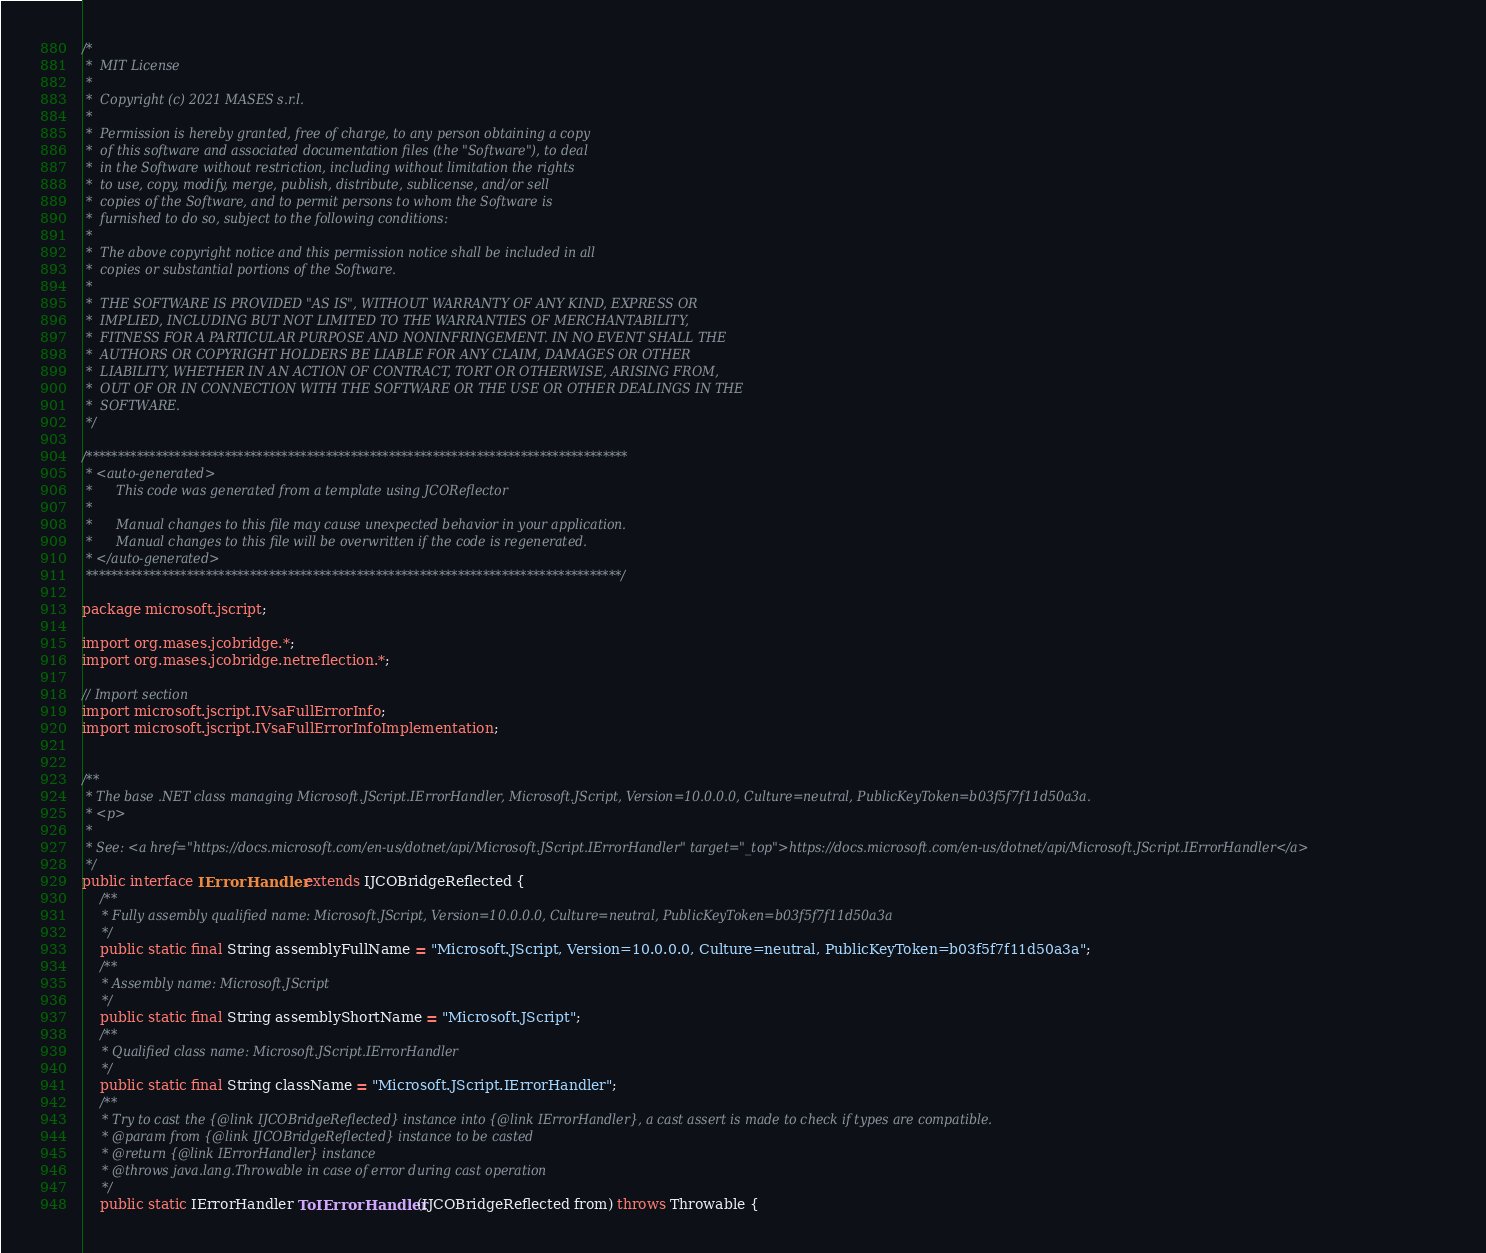Convert code to text. <code><loc_0><loc_0><loc_500><loc_500><_Java_>/*
 *  MIT License
 *
 *  Copyright (c) 2021 MASES s.r.l.
 *
 *  Permission is hereby granted, free of charge, to any person obtaining a copy
 *  of this software and associated documentation files (the "Software"), to deal
 *  in the Software without restriction, including without limitation the rights
 *  to use, copy, modify, merge, publish, distribute, sublicense, and/or sell
 *  copies of the Software, and to permit persons to whom the Software is
 *  furnished to do so, subject to the following conditions:
 *
 *  The above copyright notice and this permission notice shall be included in all
 *  copies or substantial portions of the Software.
 *
 *  THE SOFTWARE IS PROVIDED "AS IS", WITHOUT WARRANTY OF ANY KIND, EXPRESS OR
 *  IMPLIED, INCLUDING BUT NOT LIMITED TO THE WARRANTIES OF MERCHANTABILITY,
 *  FITNESS FOR A PARTICULAR PURPOSE AND NONINFRINGEMENT. IN NO EVENT SHALL THE
 *  AUTHORS OR COPYRIGHT HOLDERS BE LIABLE FOR ANY CLAIM, DAMAGES OR OTHER
 *  LIABILITY, WHETHER IN AN ACTION OF CONTRACT, TORT OR OTHERWISE, ARISING FROM,
 *  OUT OF OR IN CONNECTION WITH THE SOFTWARE OR THE USE OR OTHER DEALINGS IN THE
 *  SOFTWARE.
 */

/**************************************************************************************
 * <auto-generated>
 *      This code was generated from a template using JCOReflector
 * 
 *      Manual changes to this file may cause unexpected behavior in your application.
 *      Manual changes to this file will be overwritten if the code is regenerated.
 * </auto-generated>
 *************************************************************************************/

package microsoft.jscript;

import org.mases.jcobridge.*;
import org.mases.jcobridge.netreflection.*;

// Import section
import microsoft.jscript.IVsaFullErrorInfo;
import microsoft.jscript.IVsaFullErrorInfoImplementation;


/**
 * The base .NET class managing Microsoft.JScript.IErrorHandler, Microsoft.JScript, Version=10.0.0.0, Culture=neutral, PublicKeyToken=b03f5f7f11d50a3a.
 * <p>
 * 
 * See: <a href="https://docs.microsoft.com/en-us/dotnet/api/Microsoft.JScript.IErrorHandler" target="_top">https://docs.microsoft.com/en-us/dotnet/api/Microsoft.JScript.IErrorHandler</a>
 */
public interface IErrorHandler extends IJCOBridgeReflected {
    /**
     * Fully assembly qualified name: Microsoft.JScript, Version=10.0.0.0, Culture=neutral, PublicKeyToken=b03f5f7f11d50a3a
     */
    public static final String assemblyFullName = "Microsoft.JScript, Version=10.0.0.0, Culture=neutral, PublicKeyToken=b03f5f7f11d50a3a";
    /**
     * Assembly name: Microsoft.JScript
     */
    public static final String assemblyShortName = "Microsoft.JScript";
    /**
     * Qualified class name: Microsoft.JScript.IErrorHandler
     */
    public static final String className = "Microsoft.JScript.IErrorHandler";
    /**
     * Try to cast the {@link IJCOBridgeReflected} instance into {@link IErrorHandler}, a cast assert is made to check if types are compatible.
     * @param from {@link IJCOBridgeReflected} instance to be casted
     * @return {@link IErrorHandler} instance
     * @throws java.lang.Throwable in case of error during cast operation
     */
    public static IErrorHandler ToIErrorHandler(IJCOBridgeReflected from) throws Throwable {</code> 